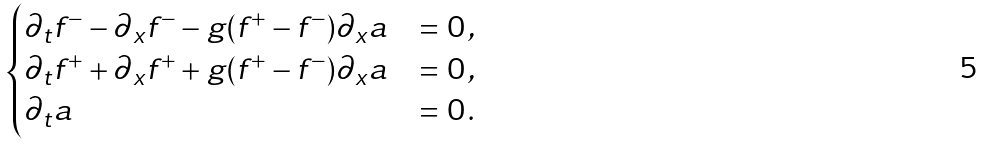Convert formula to latex. <formula><loc_0><loc_0><loc_500><loc_500>\begin{cases} \partial _ { t } f ^ { - } - \partial _ { x } f ^ { - } - g ( f ^ { + } - f ^ { - } ) \partial _ { x } a & = 0 \, , \\ \partial _ { t } f ^ { + } + \partial _ { x } f ^ { + } + g ( f ^ { + } - f ^ { - } ) \partial _ { x } a & = 0 \, , \\ \partial _ { t } a & = 0 \, . \end{cases}</formula> 